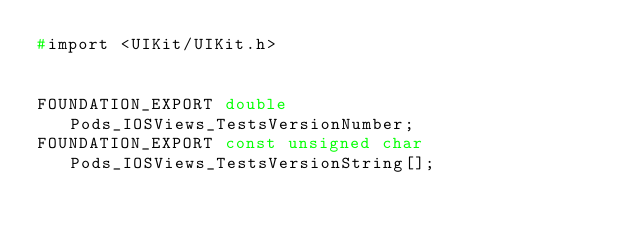Convert code to text. <code><loc_0><loc_0><loc_500><loc_500><_C_>#import <UIKit/UIKit.h>


FOUNDATION_EXPORT double Pods_IOSViews_TestsVersionNumber;
FOUNDATION_EXPORT const unsigned char Pods_IOSViews_TestsVersionString[];

</code> 